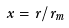<formula> <loc_0><loc_0><loc_500><loc_500>x = r / r _ { m }</formula> 